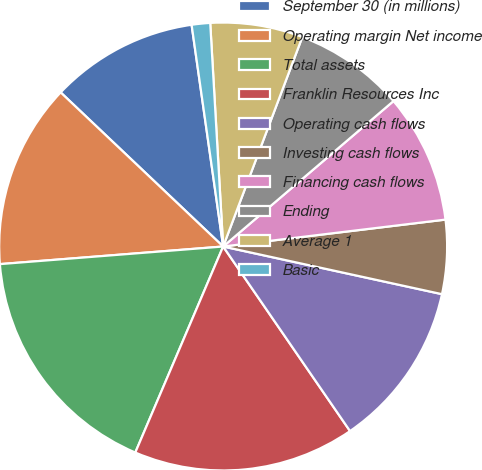Convert chart. <chart><loc_0><loc_0><loc_500><loc_500><pie_chart><fcel>September 30 (in millions)<fcel>Operating margin Net income<fcel>Total assets<fcel>Franklin Resources Inc<fcel>Operating cash flows<fcel>Investing cash flows<fcel>Financing cash flows<fcel>Ending<fcel>Average 1<fcel>Basic<nl><fcel>10.67%<fcel>13.33%<fcel>17.33%<fcel>16.0%<fcel>12.0%<fcel>5.33%<fcel>9.33%<fcel>8.0%<fcel>6.67%<fcel>1.33%<nl></chart> 